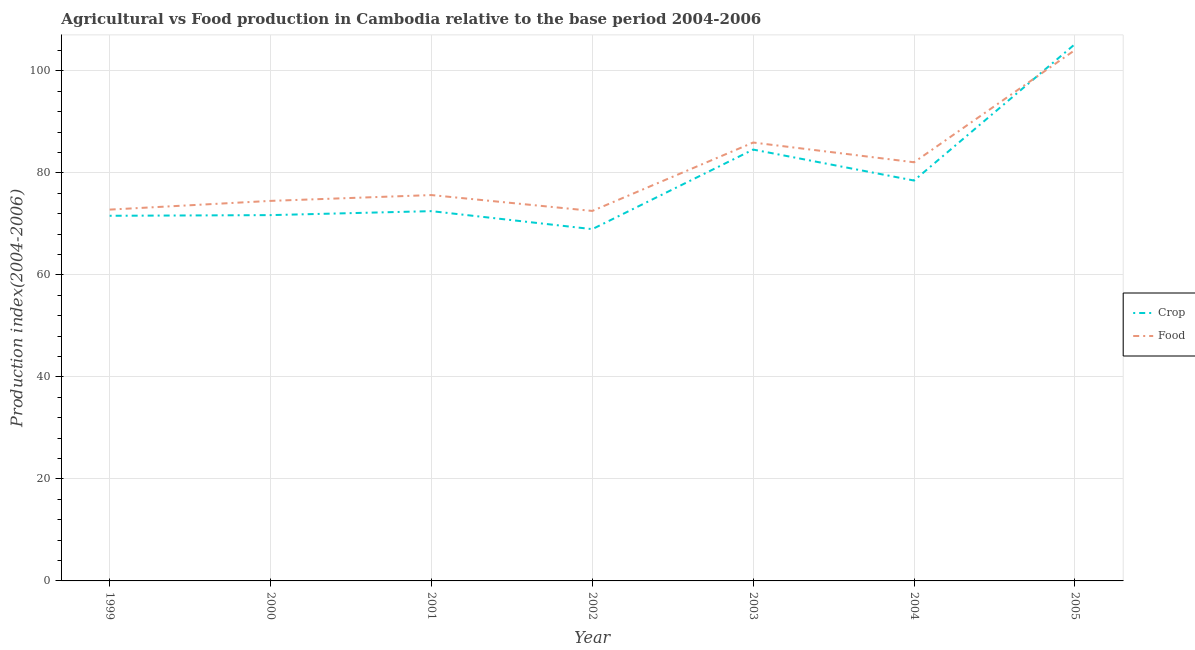How many different coloured lines are there?
Provide a short and direct response. 2. Does the line corresponding to crop production index intersect with the line corresponding to food production index?
Provide a short and direct response. Yes. What is the crop production index in 1999?
Give a very brief answer. 71.58. Across all years, what is the maximum crop production index?
Give a very brief answer. 105.23. Across all years, what is the minimum crop production index?
Ensure brevity in your answer.  68.96. What is the total food production index in the graph?
Your answer should be compact. 567.54. What is the difference between the crop production index in 2000 and that in 2003?
Make the answer very short. -12.85. What is the difference between the food production index in 2004 and the crop production index in 2001?
Provide a short and direct response. 9.58. What is the average crop production index per year?
Provide a short and direct response. 79. In the year 2001, what is the difference between the crop production index and food production index?
Your answer should be very brief. -3.15. In how many years, is the food production index greater than 56?
Offer a terse response. 7. What is the ratio of the food production index in 2000 to that in 2004?
Give a very brief answer. 0.91. What is the difference between the highest and the second highest crop production index?
Offer a terse response. 20.67. What is the difference between the highest and the lowest crop production index?
Make the answer very short. 36.27. Is the crop production index strictly less than the food production index over the years?
Give a very brief answer. No. What is the difference between two consecutive major ticks on the Y-axis?
Offer a very short reply. 20. Does the graph contain grids?
Give a very brief answer. Yes. Where does the legend appear in the graph?
Offer a very short reply. Center right. How many legend labels are there?
Your answer should be compact. 2. What is the title of the graph?
Offer a terse response. Agricultural vs Food production in Cambodia relative to the base period 2004-2006. Does "Public funds" appear as one of the legend labels in the graph?
Offer a very short reply. No. What is the label or title of the Y-axis?
Give a very brief answer. Production index(2004-2006). What is the Production index(2004-2006) in Crop in 1999?
Provide a short and direct response. 71.58. What is the Production index(2004-2006) of Food in 1999?
Keep it short and to the point. 72.79. What is the Production index(2004-2006) in Crop in 2000?
Make the answer very short. 71.71. What is the Production index(2004-2006) of Food in 2000?
Give a very brief answer. 74.5. What is the Production index(2004-2006) in Crop in 2001?
Ensure brevity in your answer.  72.49. What is the Production index(2004-2006) of Food in 2001?
Your answer should be very brief. 75.64. What is the Production index(2004-2006) in Crop in 2002?
Your answer should be very brief. 68.96. What is the Production index(2004-2006) of Food in 2002?
Provide a succinct answer. 72.53. What is the Production index(2004-2006) in Crop in 2003?
Your answer should be very brief. 84.56. What is the Production index(2004-2006) of Food in 2003?
Keep it short and to the point. 85.94. What is the Production index(2004-2006) in Crop in 2004?
Offer a very short reply. 78.49. What is the Production index(2004-2006) of Food in 2004?
Offer a terse response. 82.07. What is the Production index(2004-2006) in Crop in 2005?
Keep it short and to the point. 105.23. What is the Production index(2004-2006) of Food in 2005?
Provide a short and direct response. 104.07. Across all years, what is the maximum Production index(2004-2006) in Crop?
Provide a succinct answer. 105.23. Across all years, what is the maximum Production index(2004-2006) of Food?
Provide a short and direct response. 104.07. Across all years, what is the minimum Production index(2004-2006) in Crop?
Offer a terse response. 68.96. Across all years, what is the minimum Production index(2004-2006) of Food?
Offer a terse response. 72.53. What is the total Production index(2004-2006) in Crop in the graph?
Your answer should be very brief. 553.02. What is the total Production index(2004-2006) in Food in the graph?
Provide a short and direct response. 567.54. What is the difference between the Production index(2004-2006) in Crop in 1999 and that in 2000?
Offer a very short reply. -0.13. What is the difference between the Production index(2004-2006) in Food in 1999 and that in 2000?
Offer a terse response. -1.71. What is the difference between the Production index(2004-2006) of Crop in 1999 and that in 2001?
Give a very brief answer. -0.91. What is the difference between the Production index(2004-2006) of Food in 1999 and that in 2001?
Ensure brevity in your answer.  -2.85. What is the difference between the Production index(2004-2006) of Crop in 1999 and that in 2002?
Offer a terse response. 2.62. What is the difference between the Production index(2004-2006) of Food in 1999 and that in 2002?
Your answer should be compact. 0.26. What is the difference between the Production index(2004-2006) of Crop in 1999 and that in 2003?
Ensure brevity in your answer.  -12.98. What is the difference between the Production index(2004-2006) of Food in 1999 and that in 2003?
Give a very brief answer. -13.15. What is the difference between the Production index(2004-2006) in Crop in 1999 and that in 2004?
Provide a succinct answer. -6.91. What is the difference between the Production index(2004-2006) of Food in 1999 and that in 2004?
Keep it short and to the point. -9.28. What is the difference between the Production index(2004-2006) in Crop in 1999 and that in 2005?
Give a very brief answer. -33.65. What is the difference between the Production index(2004-2006) in Food in 1999 and that in 2005?
Provide a succinct answer. -31.28. What is the difference between the Production index(2004-2006) of Crop in 2000 and that in 2001?
Your answer should be very brief. -0.78. What is the difference between the Production index(2004-2006) of Food in 2000 and that in 2001?
Offer a very short reply. -1.14. What is the difference between the Production index(2004-2006) in Crop in 2000 and that in 2002?
Offer a terse response. 2.75. What is the difference between the Production index(2004-2006) in Food in 2000 and that in 2002?
Your response must be concise. 1.97. What is the difference between the Production index(2004-2006) in Crop in 2000 and that in 2003?
Make the answer very short. -12.85. What is the difference between the Production index(2004-2006) in Food in 2000 and that in 2003?
Offer a terse response. -11.44. What is the difference between the Production index(2004-2006) in Crop in 2000 and that in 2004?
Your response must be concise. -6.78. What is the difference between the Production index(2004-2006) of Food in 2000 and that in 2004?
Provide a short and direct response. -7.57. What is the difference between the Production index(2004-2006) in Crop in 2000 and that in 2005?
Ensure brevity in your answer.  -33.52. What is the difference between the Production index(2004-2006) in Food in 2000 and that in 2005?
Provide a short and direct response. -29.57. What is the difference between the Production index(2004-2006) in Crop in 2001 and that in 2002?
Offer a terse response. 3.53. What is the difference between the Production index(2004-2006) of Food in 2001 and that in 2002?
Provide a short and direct response. 3.11. What is the difference between the Production index(2004-2006) of Crop in 2001 and that in 2003?
Offer a very short reply. -12.07. What is the difference between the Production index(2004-2006) in Food in 2001 and that in 2003?
Offer a terse response. -10.3. What is the difference between the Production index(2004-2006) of Crop in 2001 and that in 2004?
Your response must be concise. -6. What is the difference between the Production index(2004-2006) in Food in 2001 and that in 2004?
Offer a very short reply. -6.43. What is the difference between the Production index(2004-2006) in Crop in 2001 and that in 2005?
Offer a terse response. -32.74. What is the difference between the Production index(2004-2006) of Food in 2001 and that in 2005?
Offer a terse response. -28.43. What is the difference between the Production index(2004-2006) of Crop in 2002 and that in 2003?
Make the answer very short. -15.6. What is the difference between the Production index(2004-2006) in Food in 2002 and that in 2003?
Provide a succinct answer. -13.41. What is the difference between the Production index(2004-2006) of Crop in 2002 and that in 2004?
Ensure brevity in your answer.  -9.53. What is the difference between the Production index(2004-2006) in Food in 2002 and that in 2004?
Your response must be concise. -9.54. What is the difference between the Production index(2004-2006) in Crop in 2002 and that in 2005?
Provide a short and direct response. -36.27. What is the difference between the Production index(2004-2006) of Food in 2002 and that in 2005?
Provide a succinct answer. -31.54. What is the difference between the Production index(2004-2006) in Crop in 2003 and that in 2004?
Make the answer very short. 6.07. What is the difference between the Production index(2004-2006) in Food in 2003 and that in 2004?
Your response must be concise. 3.87. What is the difference between the Production index(2004-2006) in Crop in 2003 and that in 2005?
Ensure brevity in your answer.  -20.67. What is the difference between the Production index(2004-2006) of Food in 2003 and that in 2005?
Your answer should be compact. -18.13. What is the difference between the Production index(2004-2006) of Crop in 2004 and that in 2005?
Make the answer very short. -26.74. What is the difference between the Production index(2004-2006) of Food in 2004 and that in 2005?
Your answer should be very brief. -22. What is the difference between the Production index(2004-2006) in Crop in 1999 and the Production index(2004-2006) in Food in 2000?
Ensure brevity in your answer.  -2.92. What is the difference between the Production index(2004-2006) of Crop in 1999 and the Production index(2004-2006) of Food in 2001?
Make the answer very short. -4.06. What is the difference between the Production index(2004-2006) in Crop in 1999 and the Production index(2004-2006) in Food in 2002?
Offer a terse response. -0.95. What is the difference between the Production index(2004-2006) of Crop in 1999 and the Production index(2004-2006) of Food in 2003?
Your answer should be compact. -14.36. What is the difference between the Production index(2004-2006) in Crop in 1999 and the Production index(2004-2006) in Food in 2004?
Make the answer very short. -10.49. What is the difference between the Production index(2004-2006) of Crop in 1999 and the Production index(2004-2006) of Food in 2005?
Provide a short and direct response. -32.49. What is the difference between the Production index(2004-2006) of Crop in 2000 and the Production index(2004-2006) of Food in 2001?
Make the answer very short. -3.93. What is the difference between the Production index(2004-2006) in Crop in 2000 and the Production index(2004-2006) in Food in 2002?
Your response must be concise. -0.82. What is the difference between the Production index(2004-2006) of Crop in 2000 and the Production index(2004-2006) of Food in 2003?
Provide a short and direct response. -14.23. What is the difference between the Production index(2004-2006) of Crop in 2000 and the Production index(2004-2006) of Food in 2004?
Provide a succinct answer. -10.36. What is the difference between the Production index(2004-2006) of Crop in 2000 and the Production index(2004-2006) of Food in 2005?
Offer a terse response. -32.36. What is the difference between the Production index(2004-2006) of Crop in 2001 and the Production index(2004-2006) of Food in 2002?
Give a very brief answer. -0.04. What is the difference between the Production index(2004-2006) in Crop in 2001 and the Production index(2004-2006) in Food in 2003?
Offer a very short reply. -13.45. What is the difference between the Production index(2004-2006) of Crop in 2001 and the Production index(2004-2006) of Food in 2004?
Your answer should be very brief. -9.58. What is the difference between the Production index(2004-2006) of Crop in 2001 and the Production index(2004-2006) of Food in 2005?
Your answer should be very brief. -31.58. What is the difference between the Production index(2004-2006) in Crop in 2002 and the Production index(2004-2006) in Food in 2003?
Provide a succinct answer. -16.98. What is the difference between the Production index(2004-2006) in Crop in 2002 and the Production index(2004-2006) in Food in 2004?
Give a very brief answer. -13.11. What is the difference between the Production index(2004-2006) of Crop in 2002 and the Production index(2004-2006) of Food in 2005?
Offer a terse response. -35.11. What is the difference between the Production index(2004-2006) of Crop in 2003 and the Production index(2004-2006) of Food in 2004?
Offer a terse response. 2.49. What is the difference between the Production index(2004-2006) of Crop in 2003 and the Production index(2004-2006) of Food in 2005?
Make the answer very short. -19.51. What is the difference between the Production index(2004-2006) of Crop in 2004 and the Production index(2004-2006) of Food in 2005?
Give a very brief answer. -25.58. What is the average Production index(2004-2006) of Crop per year?
Make the answer very short. 79. What is the average Production index(2004-2006) in Food per year?
Offer a very short reply. 81.08. In the year 1999, what is the difference between the Production index(2004-2006) in Crop and Production index(2004-2006) in Food?
Your answer should be compact. -1.21. In the year 2000, what is the difference between the Production index(2004-2006) of Crop and Production index(2004-2006) of Food?
Ensure brevity in your answer.  -2.79. In the year 2001, what is the difference between the Production index(2004-2006) of Crop and Production index(2004-2006) of Food?
Your answer should be compact. -3.15. In the year 2002, what is the difference between the Production index(2004-2006) in Crop and Production index(2004-2006) in Food?
Your answer should be compact. -3.57. In the year 2003, what is the difference between the Production index(2004-2006) in Crop and Production index(2004-2006) in Food?
Offer a very short reply. -1.38. In the year 2004, what is the difference between the Production index(2004-2006) of Crop and Production index(2004-2006) of Food?
Give a very brief answer. -3.58. In the year 2005, what is the difference between the Production index(2004-2006) of Crop and Production index(2004-2006) of Food?
Ensure brevity in your answer.  1.16. What is the ratio of the Production index(2004-2006) of Food in 1999 to that in 2000?
Keep it short and to the point. 0.98. What is the ratio of the Production index(2004-2006) in Crop in 1999 to that in 2001?
Make the answer very short. 0.99. What is the ratio of the Production index(2004-2006) in Food in 1999 to that in 2001?
Your answer should be very brief. 0.96. What is the ratio of the Production index(2004-2006) of Crop in 1999 to that in 2002?
Your answer should be compact. 1.04. What is the ratio of the Production index(2004-2006) of Food in 1999 to that in 2002?
Your answer should be compact. 1. What is the ratio of the Production index(2004-2006) in Crop in 1999 to that in 2003?
Your answer should be very brief. 0.85. What is the ratio of the Production index(2004-2006) in Food in 1999 to that in 2003?
Your answer should be compact. 0.85. What is the ratio of the Production index(2004-2006) in Crop in 1999 to that in 2004?
Provide a short and direct response. 0.91. What is the ratio of the Production index(2004-2006) in Food in 1999 to that in 2004?
Keep it short and to the point. 0.89. What is the ratio of the Production index(2004-2006) of Crop in 1999 to that in 2005?
Make the answer very short. 0.68. What is the ratio of the Production index(2004-2006) of Food in 1999 to that in 2005?
Your answer should be very brief. 0.7. What is the ratio of the Production index(2004-2006) of Crop in 2000 to that in 2001?
Provide a succinct answer. 0.99. What is the ratio of the Production index(2004-2006) in Food in 2000 to that in 2001?
Keep it short and to the point. 0.98. What is the ratio of the Production index(2004-2006) in Crop in 2000 to that in 2002?
Ensure brevity in your answer.  1.04. What is the ratio of the Production index(2004-2006) of Food in 2000 to that in 2002?
Offer a very short reply. 1.03. What is the ratio of the Production index(2004-2006) of Crop in 2000 to that in 2003?
Keep it short and to the point. 0.85. What is the ratio of the Production index(2004-2006) of Food in 2000 to that in 2003?
Your response must be concise. 0.87. What is the ratio of the Production index(2004-2006) of Crop in 2000 to that in 2004?
Provide a succinct answer. 0.91. What is the ratio of the Production index(2004-2006) of Food in 2000 to that in 2004?
Give a very brief answer. 0.91. What is the ratio of the Production index(2004-2006) in Crop in 2000 to that in 2005?
Your response must be concise. 0.68. What is the ratio of the Production index(2004-2006) of Food in 2000 to that in 2005?
Offer a very short reply. 0.72. What is the ratio of the Production index(2004-2006) in Crop in 2001 to that in 2002?
Give a very brief answer. 1.05. What is the ratio of the Production index(2004-2006) of Food in 2001 to that in 2002?
Offer a very short reply. 1.04. What is the ratio of the Production index(2004-2006) of Crop in 2001 to that in 2003?
Offer a very short reply. 0.86. What is the ratio of the Production index(2004-2006) in Food in 2001 to that in 2003?
Offer a very short reply. 0.88. What is the ratio of the Production index(2004-2006) of Crop in 2001 to that in 2004?
Make the answer very short. 0.92. What is the ratio of the Production index(2004-2006) in Food in 2001 to that in 2004?
Give a very brief answer. 0.92. What is the ratio of the Production index(2004-2006) of Crop in 2001 to that in 2005?
Give a very brief answer. 0.69. What is the ratio of the Production index(2004-2006) of Food in 2001 to that in 2005?
Provide a succinct answer. 0.73. What is the ratio of the Production index(2004-2006) in Crop in 2002 to that in 2003?
Your answer should be compact. 0.82. What is the ratio of the Production index(2004-2006) in Food in 2002 to that in 2003?
Offer a very short reply. 0.84. What is the ratio of the Production index(2004-2006) in Crop in 2002 to that in 2004?
Give a very brief answer. 0.88. What is the ratio of the Production index(2004-2006) in Food in 2002 to that in 2004?
Make the answer very short. 0.88. What is the ratio of the Production index(2004-2006) in Crop in 2002 to that in 2005?
Offer a very short reply. 0.66. What is the ratio of the Production index(2004-2006) of Food in 2002 to that in 2005?
Offer a terse response. 0.7. What is the ratio of the Production index(2004-2006) of Crop in 2003 to that in 2004?
Give a very brief answer. 1.08. What is the ratio of the Production index(2004-2006) in Food in 2003 to that in 2004?
Give a very brief answer. 1.05. What is the ratio of the Production index(2004-2006) in Crop in 2003 to that in 2005?
Make the answer very short. 0.8. What is the ratio of the Production index(2004-2006) of Food in 2003 to that in 2005?
Offer a very short reply. 0.83. What is the ratio of the Production index(2004-2006) of Crop in 2004 to that in 2005?
Offer a terse response. 0.75. What is the ratio of the Production index(2004-2006) in Food in 2004 to that in 2005?
Your answer should be very brief. 0.79. What is the difference between the highest and the second highest Production index(2004-2006) of Crop?
Your response must be concise. 20.67. What is the difference between the highest and the second highest Production index(2004-2006) of Food?
Your response must be concise. 18.13. What is the difference between the highest and the lowest Production index(2004-2006) in Crop?
Provide a short and direct response. 36.27. What is the difference between the highest and the lowest Production index(2004-2006) of Food?
Your answer should be compact. 31.54. 